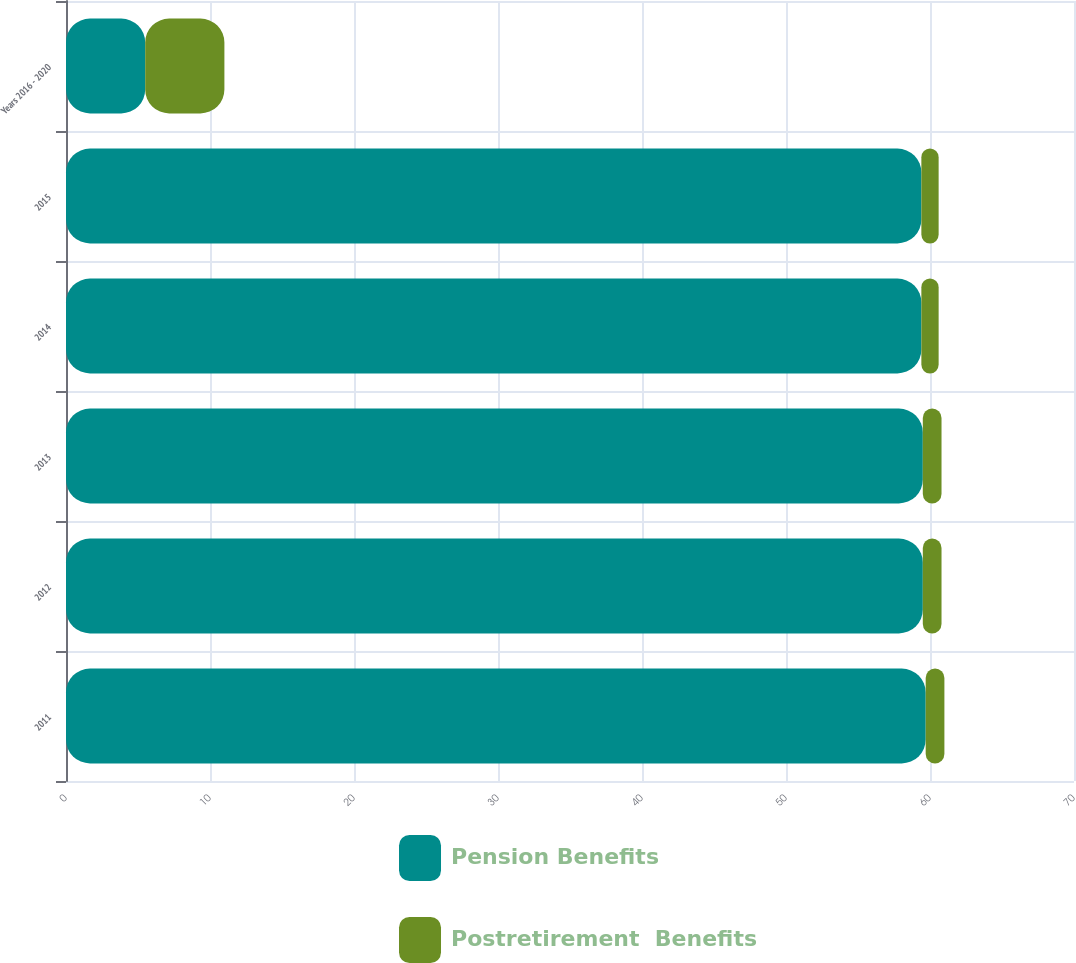Convert chart. <chart><loc_0><loc_0><loc_500><loc_500><stacked_bar_chart><ecel><fcel>2011<fcel>2012<fcel>2013<fcel>2014<fcel>2015<fcel>Years 2016 - 2020<nl><fcel>Pension Benefits<fcel>59.7<fcel>59.5<fcel>59.5<fcel>59.4<fcel>59.4<fcel>5.5<nl><fcel>Postretirement  Benefits<fcel>1.3<fcel>1.3<fcel>1.3<fcel>1.2<fcel>1.2<fcel>5.5<nl></chart> 